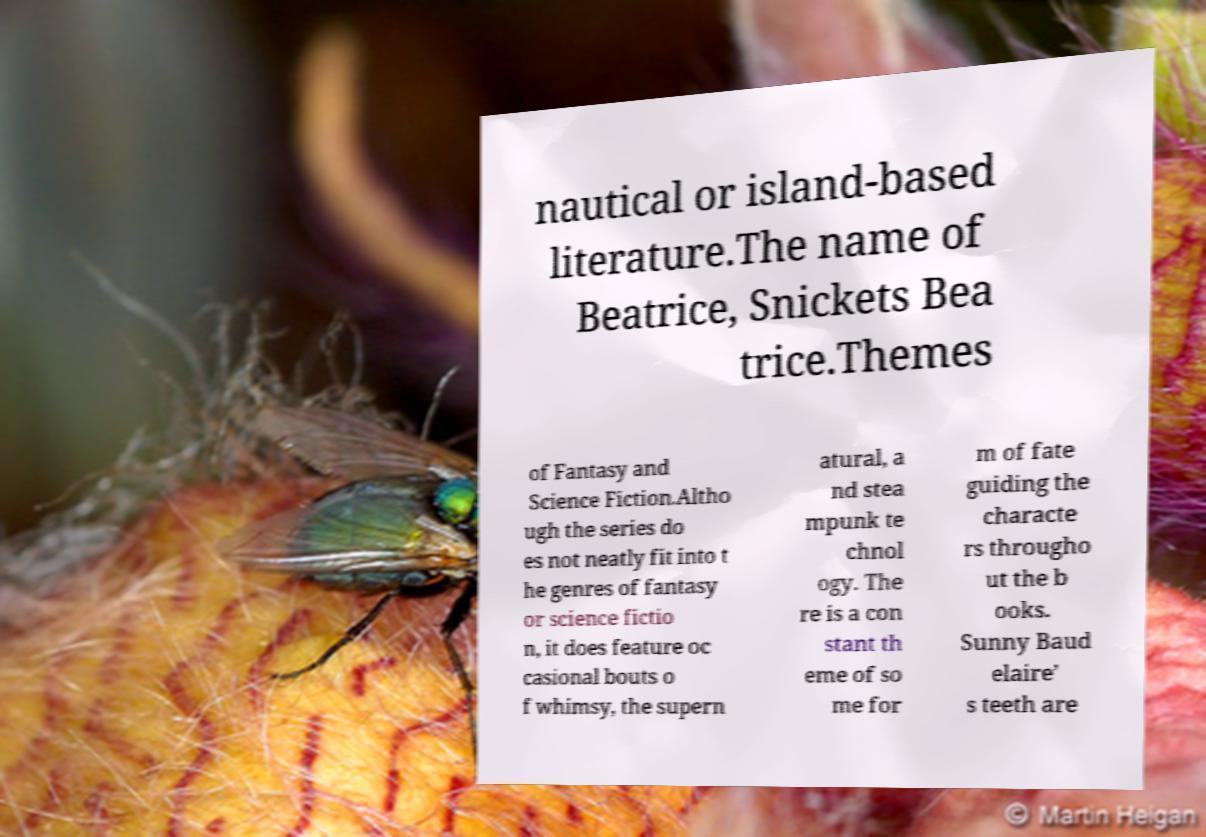Please identify and transcribe the text found in this image. nautical or island-based literature.The name of Beatrice, Snickets Bea trice.Themes of Fantasy and Science Fiction.Altho ugh the series do es not neatly fit into t he genres of fantasy or science fictio n, it does feature oc casional bouts o f whimsy, the supern atural, a nd stea mpunk te chnol ogy. The re is a con stant th eme of so me for m of fate guiding the characte rs througho ut the b ooks. Sunny Baud elaire’ s teeth are 